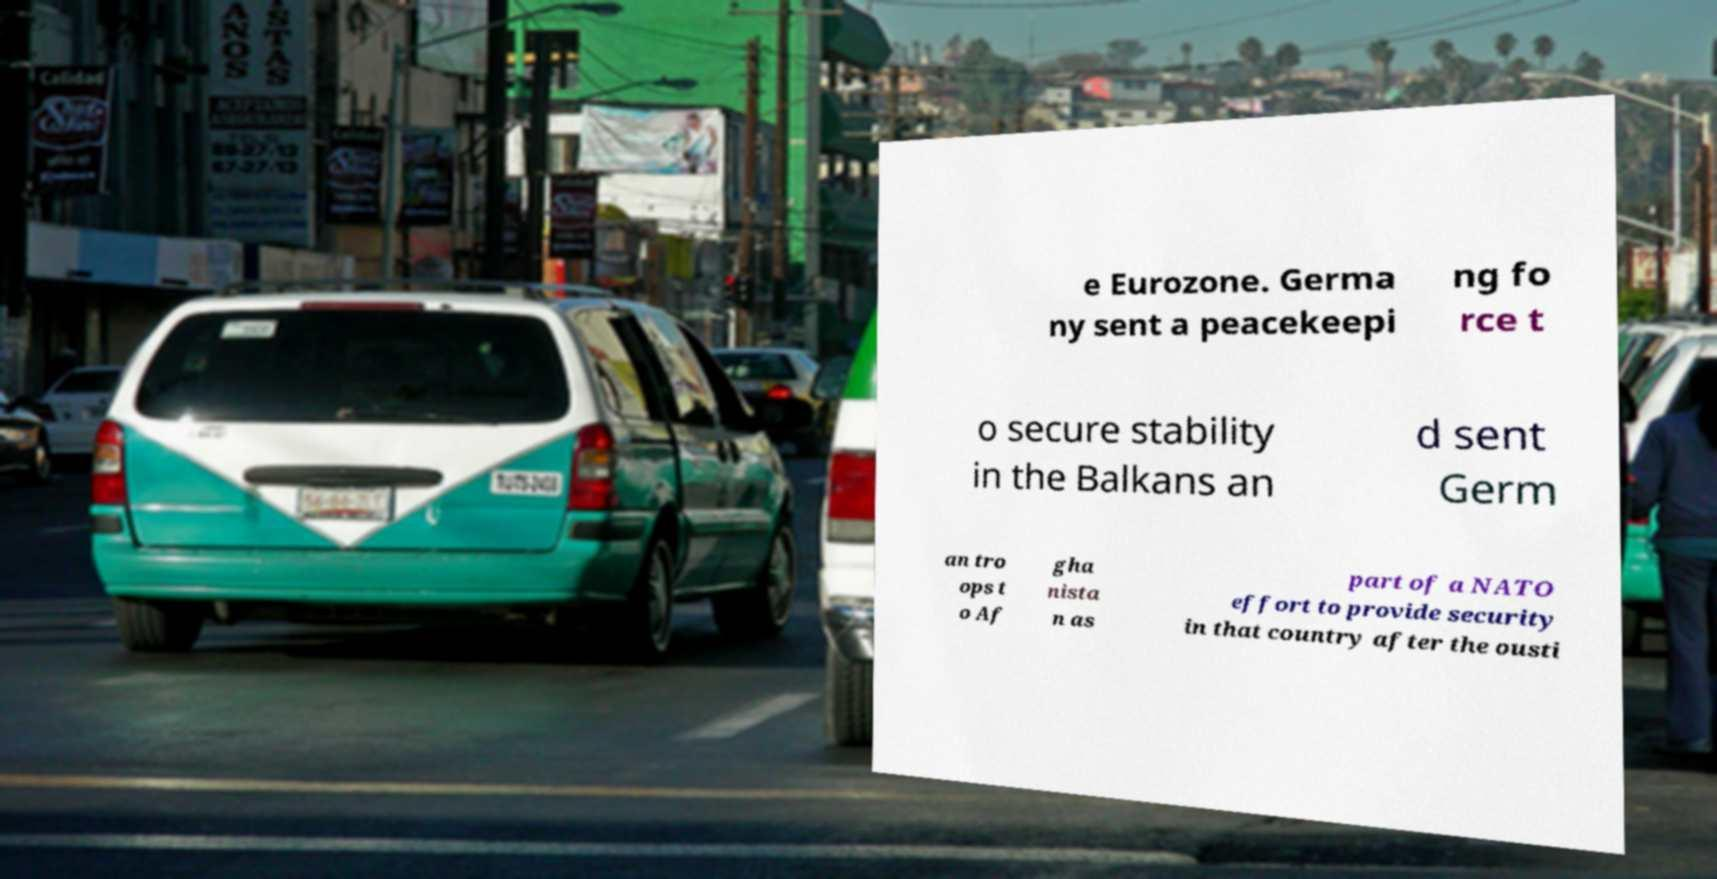Can you read and provide the text displayed in the image?This photo seems to have some interesting text. Can you extract and type it out for me? e Eurozone. Germa ny sent a peacekeepi ng fo rce t o secure stability in the Balkans an d sent Germ an tro ops t o Af gha nista n as part of a NATO effort to provide security in that country after the ousti 